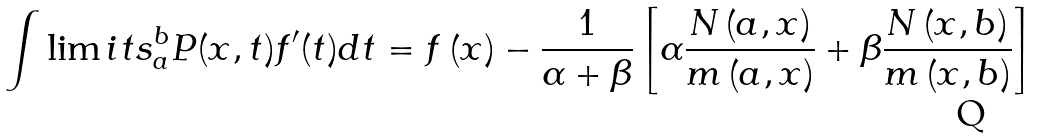Convert formula to latex. <formula><loc_0><loc_0><loc_500><loc_500>\int \lim i t s _ { a } ^ { b } P ( x , t ) f ^ { \prime } ( t ) d t = f \left ( x \right ) - \frac { 1 } { \alpha + \beta } \left [ \alpha \frac { N \left ( a , x \right ) } { m \left ( a , x \right ) } + \beta \frac { N \left ( x , b \right ) } { m \left ( x , b \right ) } \right ]</formula> 